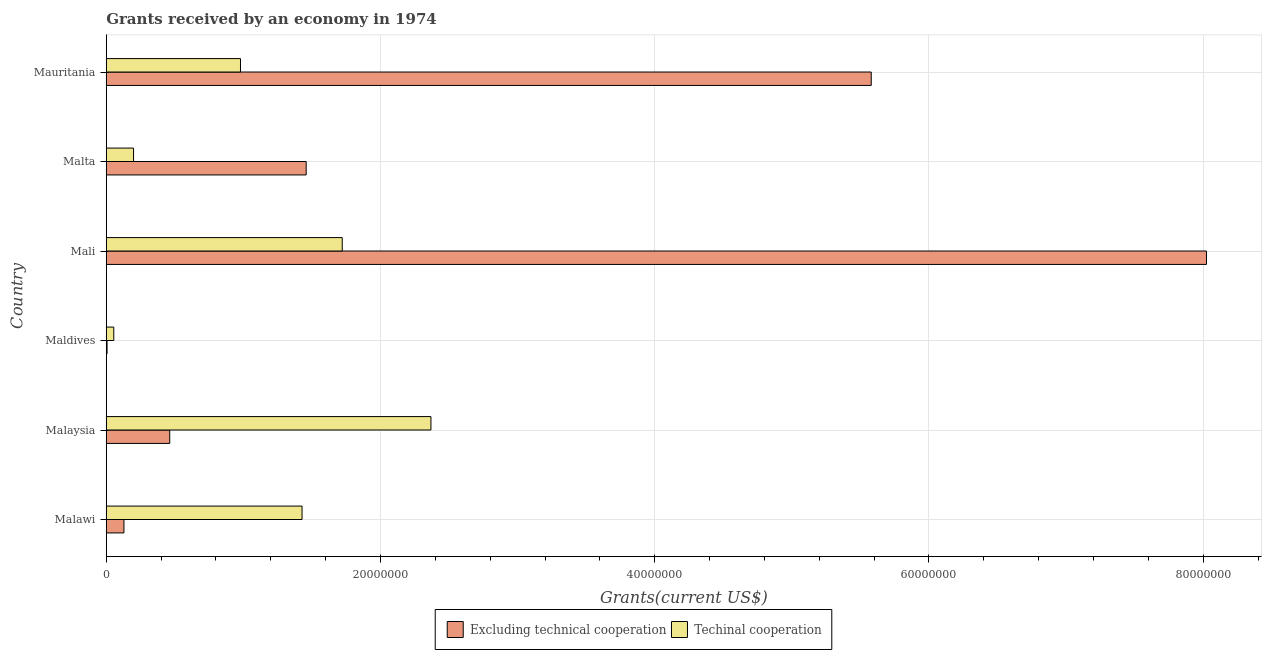How many different coloured bars are there?
Make the answer very short. 2. Are the number of bars per tick equal to the number of legend labels?
Make the answer very short. Yes. How many bars are there on the 5th tick from the bottom?
Provide a succinct answer. 2. What is the label of the 1st group of bars from the top?
Your response must be concise. Mauritania. In how many cases, is the number of bars for a given country not equal to the number of legend labels?
Give a very brief answer. 0. What is the amount of grants received(excluding technical cooperation) in Malta?
Offer a terse response. 1.46e+07. Across all countries, what is the maximum amount of grants received(including technical cooperation)?
Ensure brevity in your answer.  2.37e+07. Across all countries, what is the minimum amount of grants received(including technical cooperation)?
Ensure brevity in your answer.  5.50e+05. In which country was the amount of grants received(including technical cooperation) maximum?
Make the answer very short. Malaysia. In which country was the amount of grants received(excluding technical cooperation) minimum?
Keep it short and to the point. Maldives. What is the total amount of grants received(excluding technical cooperation) in the graph?
Offer a very short reply. 1.57e+08. What is the difference between the amount of grants received(excluding technical cooperation) in Malaysia and that in Mali?
Keep it short and to the point. -7.56e+07. What is the difference between the amount of grants received(including technical cooperation) in Malaysia and the amount of grants received(excluding technical cooperation) in Maldives?
Give a very brief answer. 2.36e+07. What is the average amount of grants received(excluding technical cooperation) per country?
Provide a short and direct response. 2.61e+07. What is the difference between the amount of grants received(including technical cooperation) and amount of grants received(excluding technical cooperation) in Malta?
Offer a very short reply. -1.26e+07. In how many countries, is the amount of grants received(excluding technical cooperation) greater than 56000000 US$?
Offer a very short reply. 1. What is the ratio of the amount of grants received(including technical cooperation) in Malawi to that in Malaysia?
Give a very brief answer. 0.6. Is the amount of grants received(including technical cooperation) in Maldives less than that in Malta?
Offer a very short reply. Yes. What is the difference between the highest and the second highest amount of grants received(excluding technical cooperation)?
Make the answer very short. 2.44e+07. What is the difference between the highest and the lowest amount of grants received(excluding technical cooperation)?
Provide a succinct answer. 8.02e+07. What does the 1st bar from the top in Malawi represents?
Make the answer very short. Techinal cooperation. What does the 2nd bar from the bottom in Malaysia represents?
Your response must be concise. Techinal cooperation. How many bars are there?
Offer a very short reply. 12. Are all the bars in the graph horizontal?
Your answer should be compact. Yes. Does the graph contain any zero values?
Ensure brevity in your answer.  No. What is the title of the graph?
Your answer should be very brief. Grants received by an economy in 1974. What is the label or title of the X-axis?
Keep it short and to the point. Grants(current US$). What is the Grants(current US$) in Excluding technical cooperation in Malawi?
Offer a very short reply. 1.29e+06. What is the Grants(current US$) in Techinal cooperation in Malawi?
Offer a terse response. 1.43e+07. What is the Grants(current US$) in Excluding technical cooperation in Malaysia?
Your answer should be very brief. 4.63e+06. What is the Grants(current US$) of Techinal cooperation in Malaysia?
Make the answer very short. 2.37e+07. What is the Grants(current US$) in Excluding technical cooperation in Maldives?
Give a very brief answer. 6.00e+04. What is the Grants(current US$) of Excluding technical cooperation in Mali?
Your answer should be compact. 8.02e+07. What is the Grants(current US$) of Techinal cooperation in Mali?
Offer a very short reply. 1.72e+07. What is the Grants(current US$) in Excluding technical cooperation in Malta?
Make the answer very short. 1.46e+07. What is the Grants(current US$) of Techinal cooperation in Malta?
Ensure brevity in your answer.  1.99e+06. What is the Grants(current US$) in Excluding technical cooperation in Mauritania?
Make the answer very short. 5.58e+07. What is the Grants(current US$) of Techinal cooperation in Mauritania?
Offer a terse response. 9.79e+06. Across all countries, what is the maximum Grants(current US$) of Excluding technical cooperation?
Ensure brevity in your answer.  8.02e+07. Across all countries, what is the maximum Grants(current US$) of Techinal cooperation?
Your answer should be compact. 2.37e+07. Across all countries, what is the minimum Grants(current US$) in Excluding technical cooperation?
Give a very brief answer. 6.00e+04. Across all countries, what is the minimum Grants(current US$) in Techinal cooperation?
Provide a short and direct response. 5.50e+05. What is the total Grants(current US$) in Excluding technical cooperation in the graph?
Offer a terse response. 1.57e+08. What is the total Grants(current US$) in Techinal cooperation in the graph?
Keep it short and to the point. 6.75e+07. What is the difference between the Grants(current US$) in Excluding technical cooperation in Malawi and that in Malaysia?
Provide a short and direct response. -3.34e+06. What is the difference between the Grants(current US$) in Techinal cooperation in Malawi and that in Malaysia?
Provide a short and direct response. -9.40e+06. What is the difference between the Grants(current US$) of Excluding technical cooperation in Malawi and that in Maldives?
Your answer should be very brief. 1.23e+06. What is the difference between the Grants(current US$) in Techinal cooperation in Malawi and that in Maldives?
Keep it short and to the point. 1.37e+07. What is the difference between the Grants(current US$) in Excluding technical cooperation in Malawi and that in Mali?
Provide a succinct answer. -7.90e+07. What is the difference between the Grants(current US$) in Techinal cooperation in Malawi and that in Mali?
Your answer should be very brief. -2.93e+06. What is the difference between the Grants(current US$) of Excluding technical cooperation in Malawi and that in Malta?
Your response must be concise. -1.33e+07. What is the difference between the Grants(current US$) of Techinal cooperation in Malawi and that in Malta?
Offer a terse response. 1.23e+07. What is the difference between the Grants(current US$) in Excluding technical cooperation in Malawi and that in Mauritania?
Provide a short and direct response. -5.45e+07. What is the difference between the Grants(current US$) of Techinal cooperation in Malawi and that in Mauritania?
Provide a short and direct response. 4.49e+06. What is the difference between the Grants(current US$) in Excluding technical cooperation in Malaysia and that in Maldives?
Your answer should be very brief. 4.57e+06. What is the difference between the Grants(current US$) in Techinal cooperation in Malaysia and that in Maldives?
Offer a terse response. 2.31e+07. What is the difference between the Grants(current US$) in Excluding technical cooperation in Malaysia and that in Mali?
Make the answer very short. -7.56e+07. What is the difference between the Grants(current US$) of Techinal cooperation in Malaysia and that in Mali?
Provide a short and direct response. 6.47e+06. What is the difference between the Grants(current US$) of Excluding technical cooperation in Malaysia and that in Malta?
Offer a terse response. -9.95e+06. What is the difference between the Grants(current US$) in Techinal cooperation in Malaysia and that in Malta?
Offer a terse response. 2.17e+07. What is the difference between the Grants(current US$) of Excluding technical cooperation in Malaysia and that in Mauritania?
Keep it short and to the point. -5.12e+07. What is the difference between the Grants(current US$) in Techinal cooperation in Malaysia and that in Mauritania?
Provide a succinct answer. 1.39e+07. What is the difference between the Grants(current US$) of Excluding technical cooperation in Maldives and that in Mali?
Make the answer very short. -8.02e+07. What is the difference between the Grants(current US$) in Techinal cooperation in Maldives and that in Mali?
Provide a succinct answer. -1.67e+07. What is the difference between the Grants(current US$) in Excluding technical cooperation in Maldives and that in Malta?
Your answer should be compact. -1.45e+07. What is the difference between the Grants(current US$) of Techinal cooperation in Maldives and that in Malta?
Your response must be concise. -1.44e+06. What is the difference between the Grants(current US$) of Excluding technical cooperation in Maldives and that in Mauritania?
Provide a short and direct response. -5.57e+07. What is the difference between the Grants(current US$) in Techinal cooperation in Maldives and that in Mauritania?
Keep it short and to the point. -9.24e+06. What is the difference between the Grants(current US$) of Excluding technical cooperation in Mali and that in Malta?
Provide a short and direct response. 6.57e+07. What is the difference between the Grants(current US$) of Techinal cooperation in Mali and that in Malta?
Offer a very short reply. 1.52e+07. What is the difference between the Grants(current US$) in Excluding technical cooperation in Mali and that in Mauritania?
Your answer should be compact. 2.44e+07. What is the difference between the Grants(current US$) in Techinal cooperation in Mali and that in Mauritania?
Offer a terse response. 7.42e+06. What is the difference between the Grants(current US$) of Excluding technical cooperation in Malta and that in Mauritania?
Give a very brief answer. -4.12e+07. What is the difference between the Grants(current US$) in Techinal cooperation in Malta and that in Mauritania?
Your answer should be very brief. -7.80e+06. What is the difference between the Grants(current US$) in Excluding technical cooperation in Malawi and the Grants(current US$) in Techinal cooperation in Malaysia?
Offer a terse response. -2.24e+07. What is the difference between the Grants(current US$) of Excluding technical cooperation in Malawi and the Grants(current US$) of Techinal cooperation in Maldives?
Provide a succinct answer. 7.40e+05. What is the difference between the Grants(current US$) of Excluding technical cooperation in Malawi and the Grants(current US$) of Techinal cooperation in Mali?
Ensure brevity in your answer.  -1.59e+07. What is the difference between the Grants(current US$) of Excluding technical cooperation in Malawi and the Grants(current US$) of Techinal cooperation in Malta?
Your response must be concise. -7.00e+05. What is the difference between the Grants(current US$) in Excluding technical cooperation in Malawi and the Grants(current US$) in Techinal cooperation in Mauritania?
Your answer should be very brief. -8.50e+06. What is the difference between the Grants(current US$) of Excluding technical cooperation in Malaysia and the Grants(current US$) of Techinal cooperation in Maldives?
Keep it short and to the point. 4.08e+06. What is the difference between the Grants(current US$) of Excluding technical cooperation in Malaysia and the Grants(current US$) of Techinal cooperation in Mali?
Your response must be concise. -1.26e+07. What is the difference between the Grants(current US$) in Excluding technical cooperation in Malaysia and the Grants(current US$) in Techinal cooperation in Malta?
Provide a short and direct response. 2.64e+06. What is the difference between the Grants(current US$) in Excluding technical cooperation in Malaysia and the Grants(current US$) in Techinal cooperation in Mauritania?
Keep it short and to the point. -5.16e+06. What is the difference between the Grants(current US$) of Excluding technical cooperation in Maldives and the Grants(current US$) of Techinal cooperation in Mali?
Ensure brevity in your answer.  -1.72e+07. What is the difference between the Grants(current US$) in Excluding technical cooperation in Maldives and the Grants(current US$) in Techinal cooperation in Malta?
Keep it short and to the point. -1.93e+06. What is the difference between the Grants(current US$) of Excluding technical cooperation in Maldives and the Grants(current US$) of Techinal cooperation in Mauritania?
Provide a succinct answer. -9.73e+06. What is the difference between the Grants(current US$) of Excluding technical cooperation in Mali and the Grants(current US$) of Techinal cooperation in Malta?
Give a very brief answer. 7.82e+07. What is the difference between the Grants(current US$) in Excluding technical cooperation in Mali and the Grants(current US$) in Techinal cooperation in Mauritania?
Make the answer very short. 7.04e+07. What is the difference between the Grants(current US$) of Excluding technical cooperation in Malta and the Grants(current US$) of Techinal cooperation in Mauritania?
Provide a succinct answer. 4.79e+06. What is the average Grants(current US$) of Excluding technical cooperation per country?
Offer a terse response. 2.61e+07. What is the average Grants(current US$) in Techinal cooperation per country?
Offer a very short reply. 1.12e+07. What is the difference between the Grants(current US$) in Excluding technical cooperation and Grants(current US$) in Techinal cooperation in Malawi?
Provide a short and direct response. -1.30e+07. What is the difference between the Grants(current US$) of Excluding technical cooperation and Grants(current US$) of Techinal cooperation in Malaysia?
Provide a short and direct response. -1.90e+07. What is the difference between the Grants(current US$) in Excluding technical cooperation and Grants(current US$) in Techinal cooperation in Maldives?
Ensure brevity in your answer.  -4.90e+05. What is the difference between the Grants(current US$) in Excluding technical cooperation and Grants(current US$) in Techinal cooperation in Mali?
Your answer should be very brief. 6.30e+07. What is the difference between the Grants(current US$) in Excluding technical cooperation and Grants(current US$) in Techinal cooperation in Malta?
Keep it short and to the point. 1.26e+07. What is the difference between the Grants(current US$) of Excluding technical cooperation and Grants(current US$) of Techinal cooperation in Mauritania?
Provide a short and direct response. 4.60e+07. What is the ratio of the Grants(current US$) in Excluding technical cooperation in Malawi to that in Malaysia?
Offer a terse response. 0.28. What is the ratio of the Grants(current US$) of Techinal cooperation in Malawi to that in Malaysia?
Your answer should be very brief. 0.6. What is the ratio of the Grants(current US$) of Techinal cooperation in Malawi to that in Maldives?
Offer a very short reply. 25.96. What is the ratio of the Grants(current US$) in Excluding technical cooperation in Malawi to that in Mali?
Give a very brief answer. 0.02. What is the ratio of the Grants(current US$) in Techinal cooperation in Malawi to that in Mali?
Ensure brevity in your answer.  0.83. What is the ratio of the Grants(current US$) of Excluding technical cooperation in Malawi to that in Malta?
Give a very brief answer. 0.09. What is the ratio of the Grants(current US$) in Techinal cooperation in Malawi to that in Malta?
Ensure brevity in your answer.  7.18. What is the ratio of the Grants(current US$) of Excluding technical cooperation in Malawi to that in Mauritania?
Your answer should be compact. 0.02. What is the ratio of the Grants(current US$) in Techinal cooperation in Malawi to that in Mauritania?
Provide a succinct answer. 1.46. What is the ratio of the Grants(current US$) in Excluding technical cooperation in Malaysia to that in Maldives?
Offer a very short reply. 77.17. What is the ratio of the Grants(current US$) of Techinal cooperation in Malaysia to that in Maldives?
Offer a very short reply. 43.05. What is the ratio of the Grants(current US$) in Excluding technical cooperation in Malaysia to that in Mali?
Provide a short and direct response. 0.06. What is the ratio of the Grants(current US$) in Techinal cooperation in Malaysia to that in Mali?
Provide a short and direct response. 1.38. What is the ratio of the Grants(current US$) in Excluding technical cooperation in Malaysia to that in Malta?
Your response must be concise. 0.32. What is the ratio of the Grants(current US$) in Techinal cooperation in Malaysia to that in Malta?
Your answer should be very brief. 11.9. What is the ratio of the Grants(current US$) in Excluding technical cooperation in Malaysia to that in Mauritania?
Offer a terse response. 0.08. What is the ratio of the Grants(current US$) of Techinal cooperation in Malaysia to that in Mauritania?
Keep it short and to the point. 2.42. What is the ratio of the Grants(current US$) of Excluding technical cooperation in Maldives to that in Mali?
Your answer should be very brief. 0. What is the ratio of the Grants(current US$) of Techinal cooperation in Maldives to that in Mali?
Your response must be concise. 0.03. What is the ratio of the Grants(current US$) in Excluding technical cooperation in Maldives to that in Malta?
Keep it short and to the point. 0. What is the ratio of the Grants(current US$) of Techinal cooperation in Maldives to that in Malta?
Your answer should be compact. 0.28. What is the ratio of the Grants(current US$) in Excluding technical cooperation in Maldives to that in Mauritania?
Ensure brevity in your answer.  0. What is the ratio of the Grants(current US$) of Techinal cooperation in Maldives to that in Mauritania?
Make the answer very short. 0.06. What is the ratio of the Grants(current US$) of Excluding technical cooperation in Mali to that in Malta?
Offer a terse response. 5.5. What is the ratio of the Grants(current US$) of Techinal cooperation in Mali to that in Malta?
Your answer should be compact. 8.65. What is the ratio of the Grants(current US$) in Excluding technical cooperation in Mali to that in Mauritania?
Your answer should be compact. 1.44. What is the ratio of the Grants(current US$) of Techinal cooperation in Mali to that in Mauritania?
Keep it short and to the point. 1.76. What is the ratio of the Grants(current US$) of Excluding technical cooperation in Malta to that in Mauritania?
Offer a very short reply. 0.26. What is the ratio of the Grants(current US$) in Techinal cooperation in Malta to that in Mauritania?
Your answer should be very brief. 0.2. What is the difference between the highest and the second highest Grants(current US$) in Excluding technical cooperation?
Your answer should be very brief. 2.44e+07. What is the difference between the highest and the second highest Grants(current US$) of Techinal cooperation?
Your answer should be very brief. 6.47e+06. What is the difference between the highest and the lowest Grants(current US$) in Excluding technical cooperation?
Ensure brevity in your answer.  8.02e+07. What is the difference between the highest and the lowest Grants(current US$) of Techinal cooperation?
Offer a very short reply. 2.31e+07. 